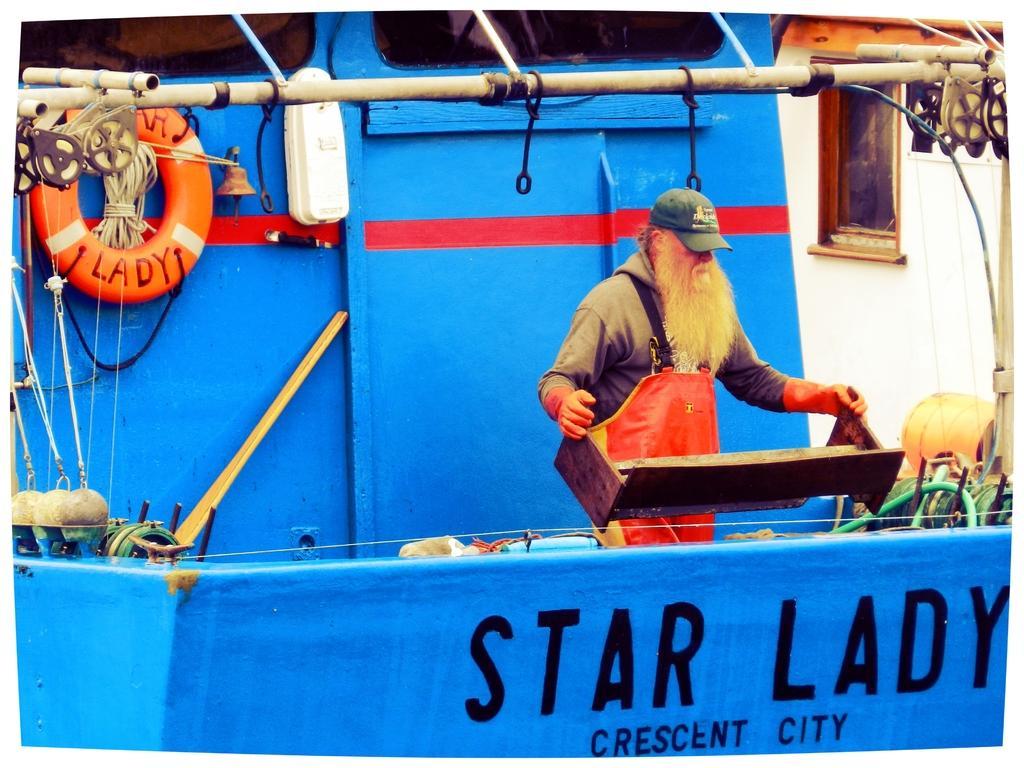Describe this image in one or two sentences. In this picture there is a man who is wearing cap, hood and apron. He is holding the wooden table. He is standing on the ship. On the left I can see some ropes which are connected to the pole. At the top I can see the windows. On the right there is a building. 